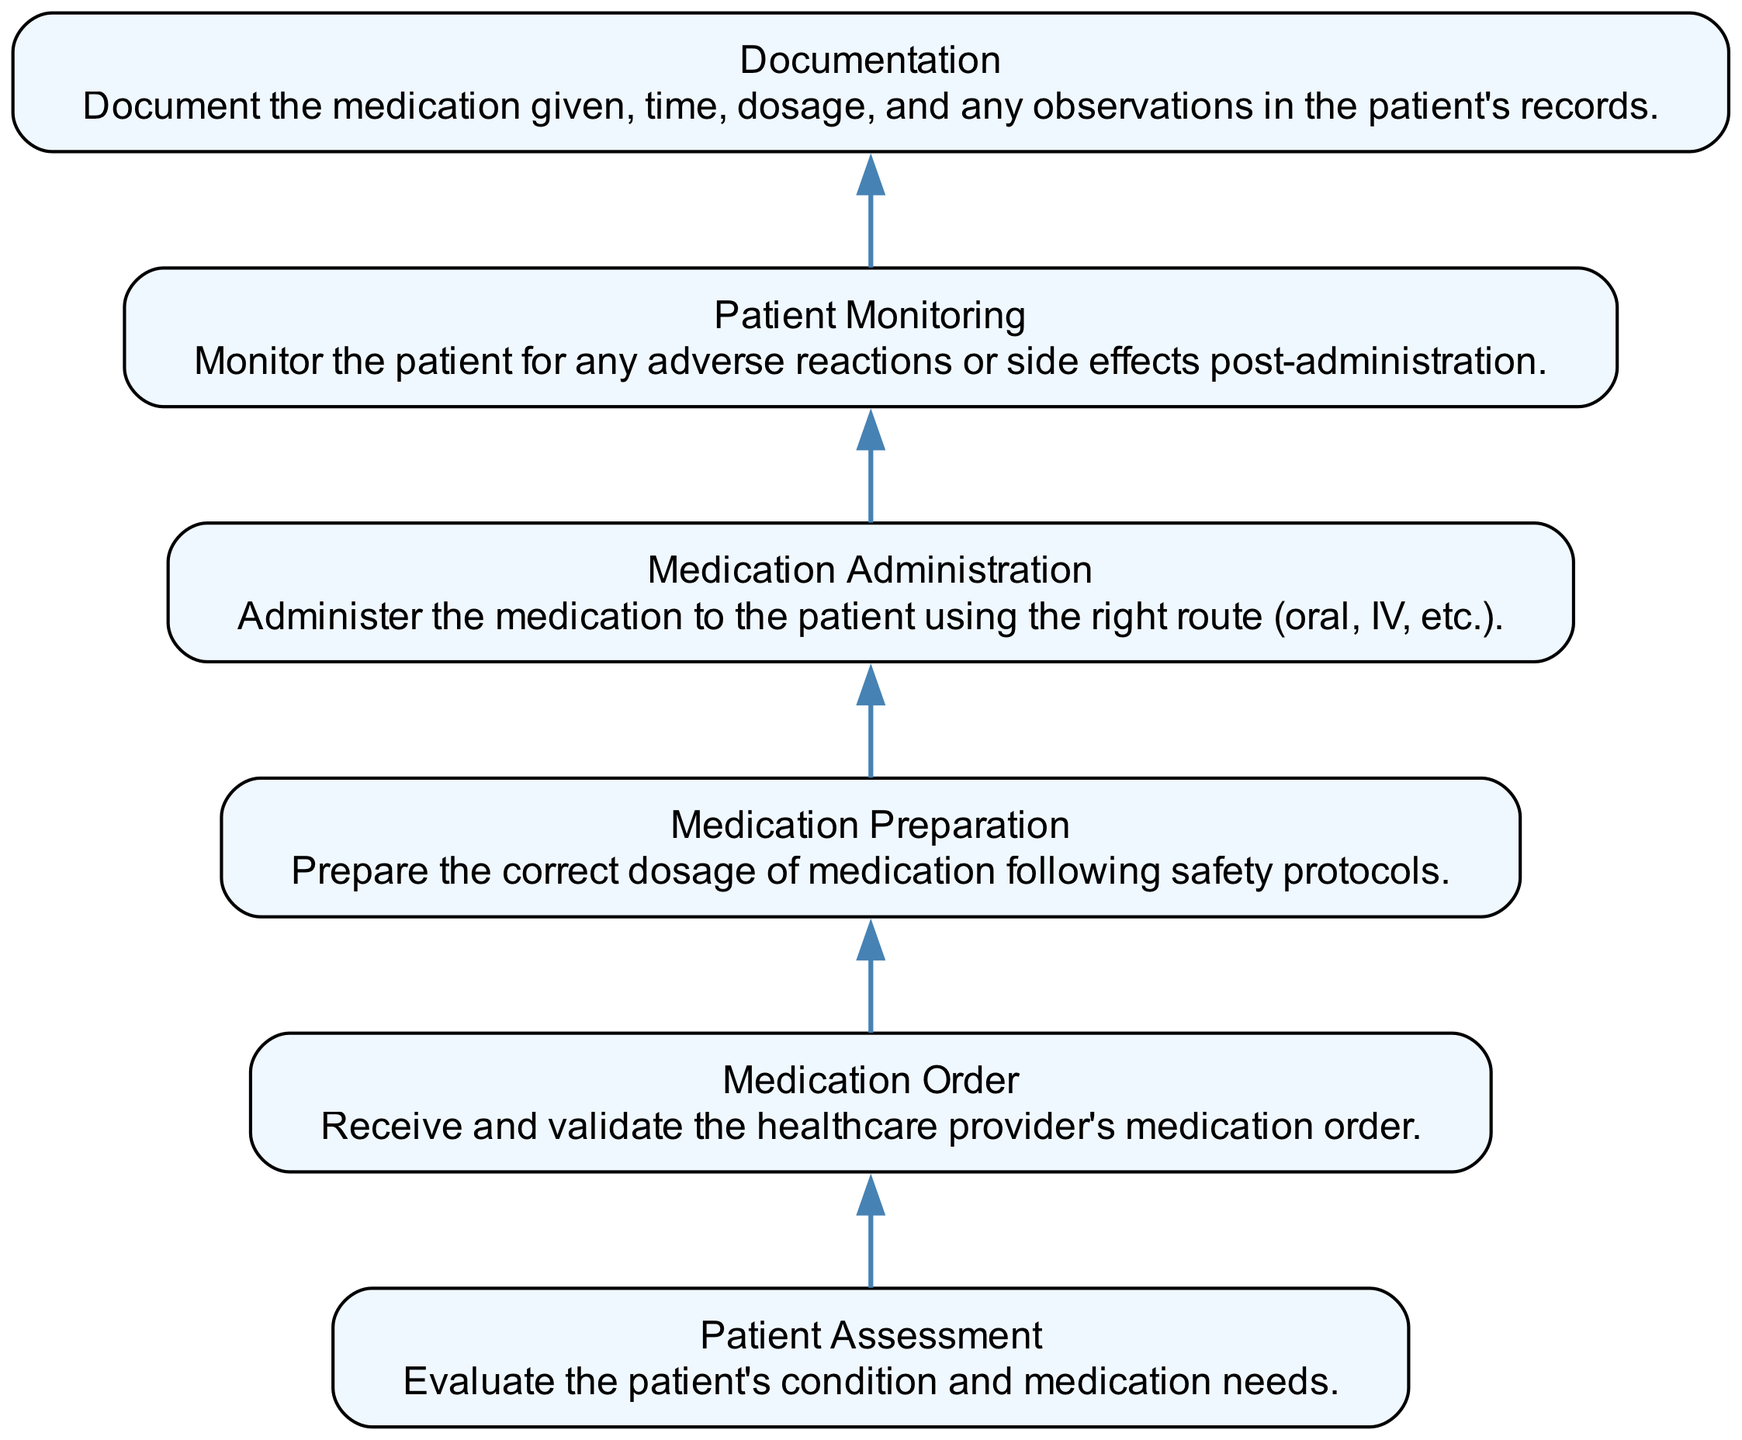What is the first step in the medication administration workflow? The first step is "Patient Assessment," which involves evaluating the patient's condition and medication needs. This is the starting node in the diagram, indicating the beginning of the workflow.
Answer: Patient Assessment How many nodes are in the diagram? The diagram contains six nodes, each representing a distinct step in the medication administration workflow. This can be counted by identifying each labeled section within the diagram.
Answer: Six What is the last step before documentation? The last step before documentation is "Patient Monitoring." This step focuses on observing the patient for any adverse reactions or side effects after medication administration, and it's directly connected to the documentation phase.
Answer: Patient Monitoring What follows medication preparation? "Medication Administration" follows "Medication Preparation." This indicates that after preparing the medication, the next action is to administer it to the patient. The flow of the diagram illustrates this transition clearly.
Answer: Medication Administration What is the primary action of the second step? The primary action of the second step, "Medication Order," is to receive and validate the healthcare provider's medication order. This is essential for ensuring that the medication provided to the patient is appropriate and safe.
Answer: Receive and validate What relationship exists between patient monitoring and documentation? There is a direct sequential relationship. "Patient Monitoring" must occur before "Documentation," indicating that monitoring the patient’s response is necessary before recording the medication details in the patient's record.
Answer: Sequential Which step directly precedes medication administration? "Medication Preparation" directly precedes "Medication Administration." This means that once the medication has been adequately prepared, it is then administered to the patient as the next step in the workflow.
Answer: Medication Preparation What is the direct effect of patient assessment on the workflow? The direct effect of "Patient Assessment" is to initiate the entire workflow, leading to the subsequent steps like medication order, preparation, and administration. It sets the pathway for effective medication management by understanding patient needs first.
Answer: Initiation 